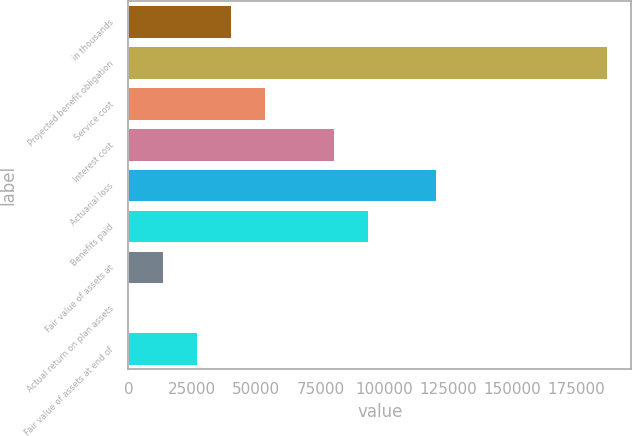Convert chart to OTSL. <chart><loc_0><loc_0><loc_500><loc_500><bar_chart><fcel>in thousands<fcel>Projected benefit obligation<fcel>Service cost<fcel>Interest cost<fcel>Actuarial loss<fcel>Benefits paid<fcel>Fair value of assets at<fcel>Actual return on plan assets<fcel>Fair value of assets at end of<nl><fcel>40115.8<fcel>187203<fcel>53487.4<fcel>80230.6<fcel>120345<fcel>93602.2<fcel>13372.6<fcel>1.06<fcel>26744.2<nl></chart> 